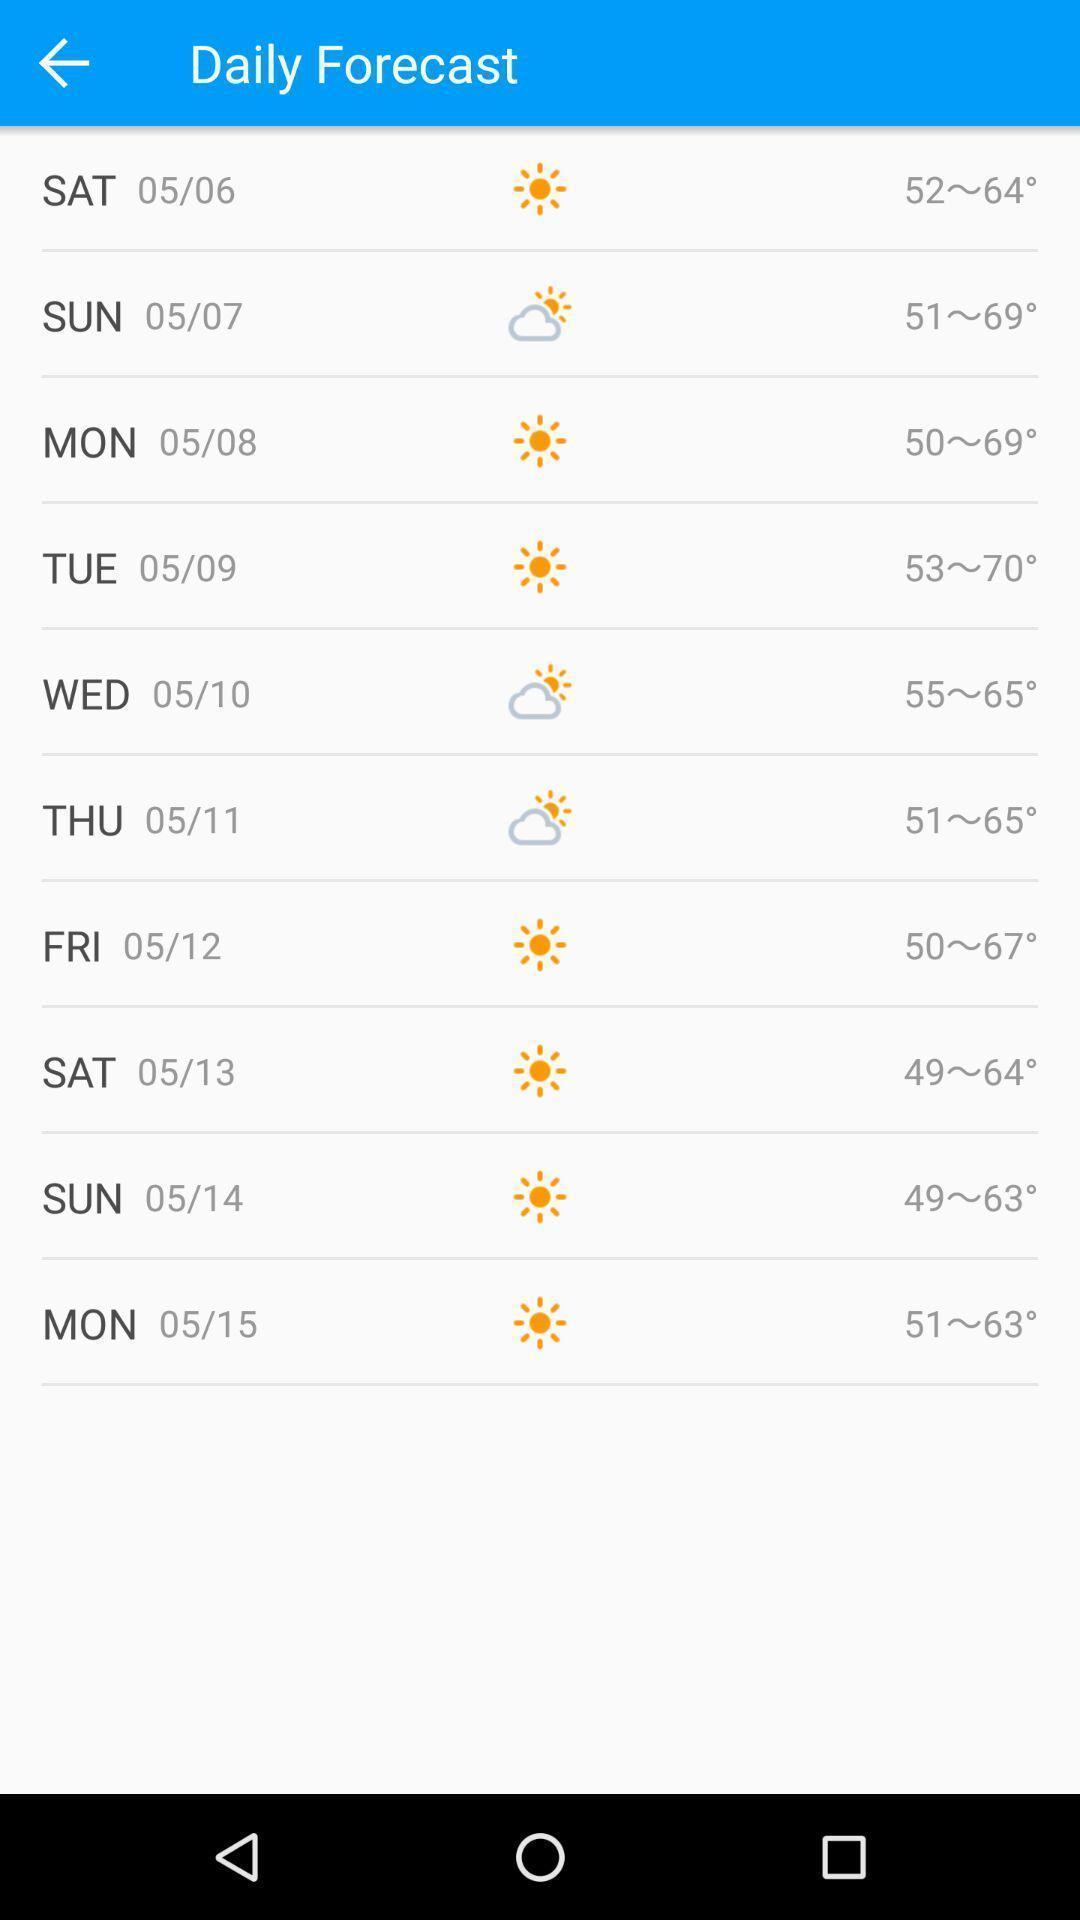Tell me about the visual elements in this screen capture. Screen display daily forecast page in a weather app. 